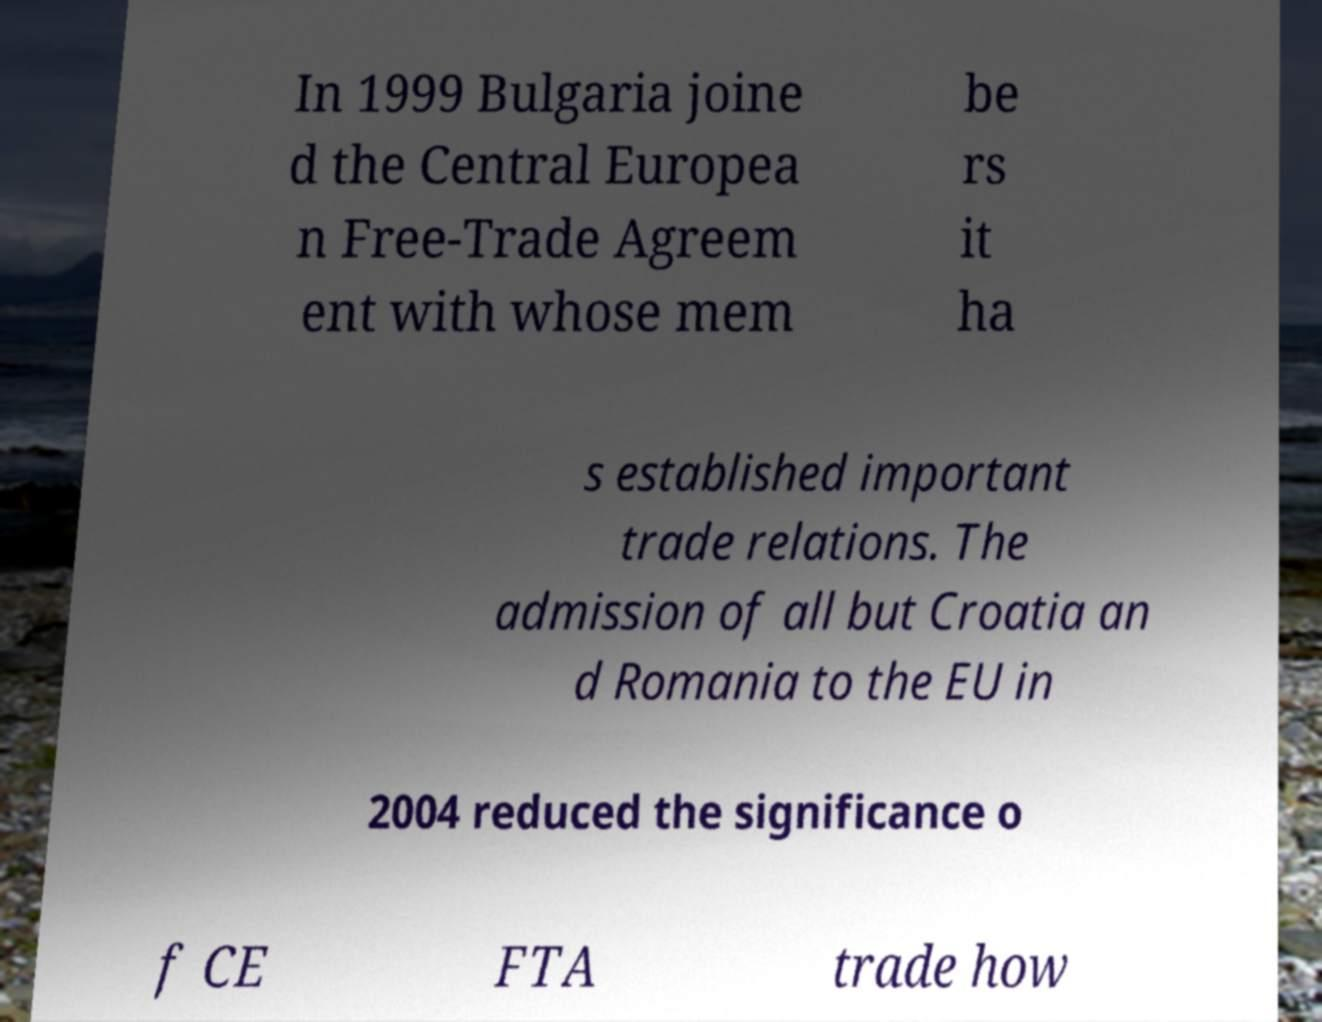What messages or text are displayed in this image? I need them in a readable, typed format. In 1999 Bulgaria joine d the Central Europea n Free-Trade Agreem ent with whose mem be rs it ha s established important trade relations. The admission of all but Croatia an d Romania to the EU in 2004 reduced the significance o f CE FTA trade how 